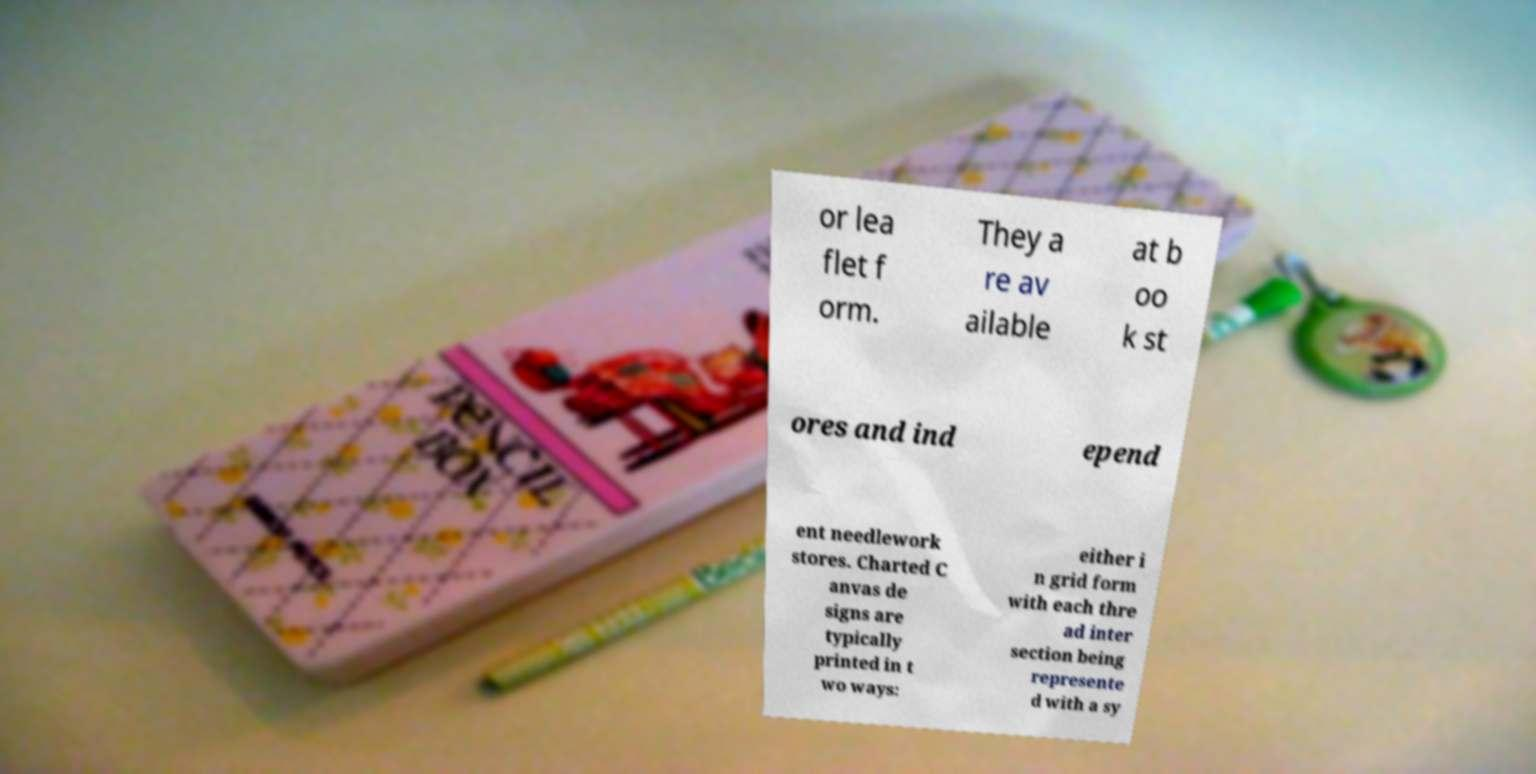There's text embedded in this image that I need extracted. Can you transcribe it verbatim? or lea flet f orm. They a re av ailable at b oo k st ores and ind epend ent needlework stores. Charted C anvas de signs are typically printed in t wo ways: either i n grid form with each thre ad inter section being represente d with a sy 